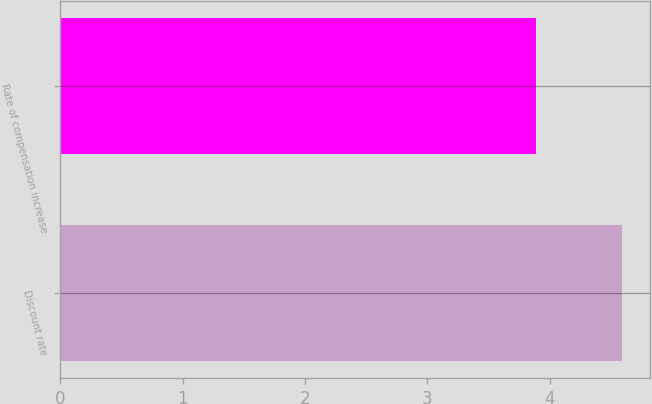<chart> <loc_0><loc_0><loc_500><loc_500><bar_chart><fcel>Discount rate<fcel>Rate of compensation increase<nl><fcel>4.59<fcel>3.89<nl></chart> 